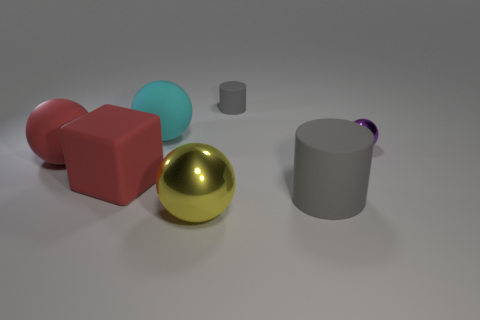Subtract all purple spheres. How many spheres are left? 3 Subtract all big red balls. How many balls are left? 3 Subtract all green spheres. Subtract all green blocks. How many spheres are left? 4 Add 1 big red matte balls. How many objects exist? 8 Subtract all blocks. How many objects are left? 6 Subtract 0 gray balls. How many objects are left? 7 Subtract all big matte balls. Subtract all red matte objects. How many objects are left? 3 Add 4 gray matte things. How many gray matte things are left? 6 Add 6 small cyan matte things. How many small cyan matte things exist? 6 